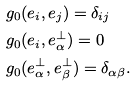<formula> <loc_0><loc_0><loc_500><loc_500>& g _ { 0 } ( e _ { i } , e _ { j } ) = \delta _ { i j } \\ & g _ { 0 } ( e _ { i } , e _ { \alpha } ^ { \perp } ) = 0 \\ & g _ { 0 } ( e _ { \alpha } ^ { \perp } , e _ { \beta } ^ { \perp } ) = \delta _ { \alpha \beta } .</formula> 